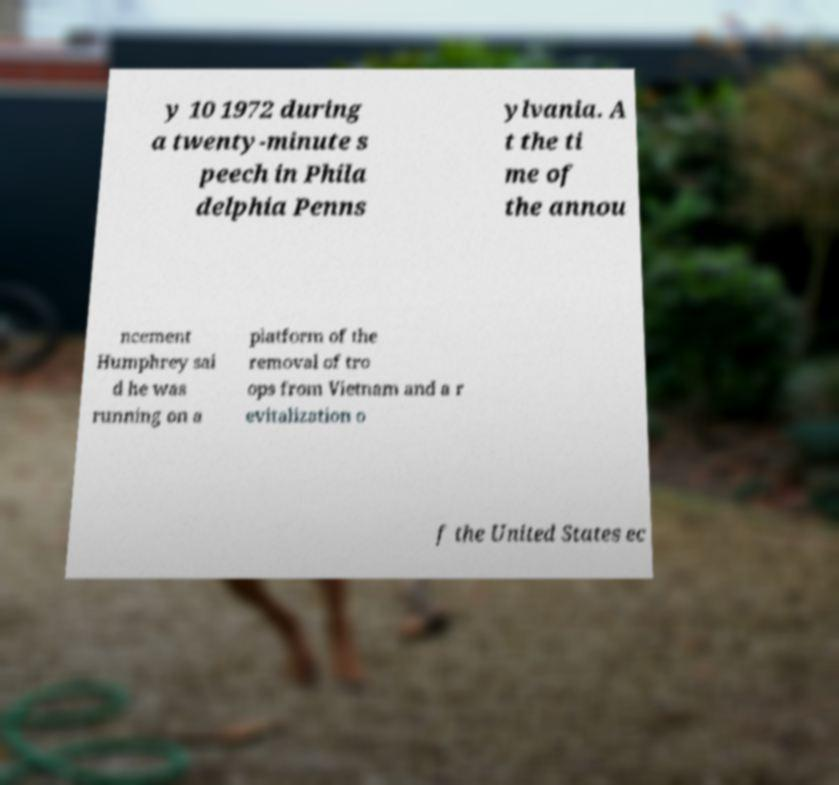Please identify and transcribe the text found in this image. y 10 1972 during a twenty-minute s peech in Phila delphia Penns ylvania. A t the ti me of the annou ncement Humphrey sai d he was running on a platform of the removal of tro ops from Vietnam and a r evitalization o f the United States ec 